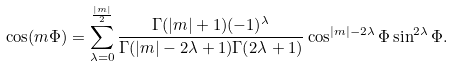Convert formula to latex. <formula><loc_0><loc_0><loc_500><loc_500>\cos ( m \Phi ) = \sum _ { \lambda = 0 } ^ { \frac { | m | } { 2 } } \frac { \Gamma ( | m | + 1 ) ( - 1 ) ^ { \lambda } } { \Gamma ( | m | - 2 \lambda + 1 ) \Gamma ( 2 \lambda + 1 ) } \cos ^ { | m | - 2 \lambda } \Phi \sin ^ { 2 \lambda } \Phi .</formula> 